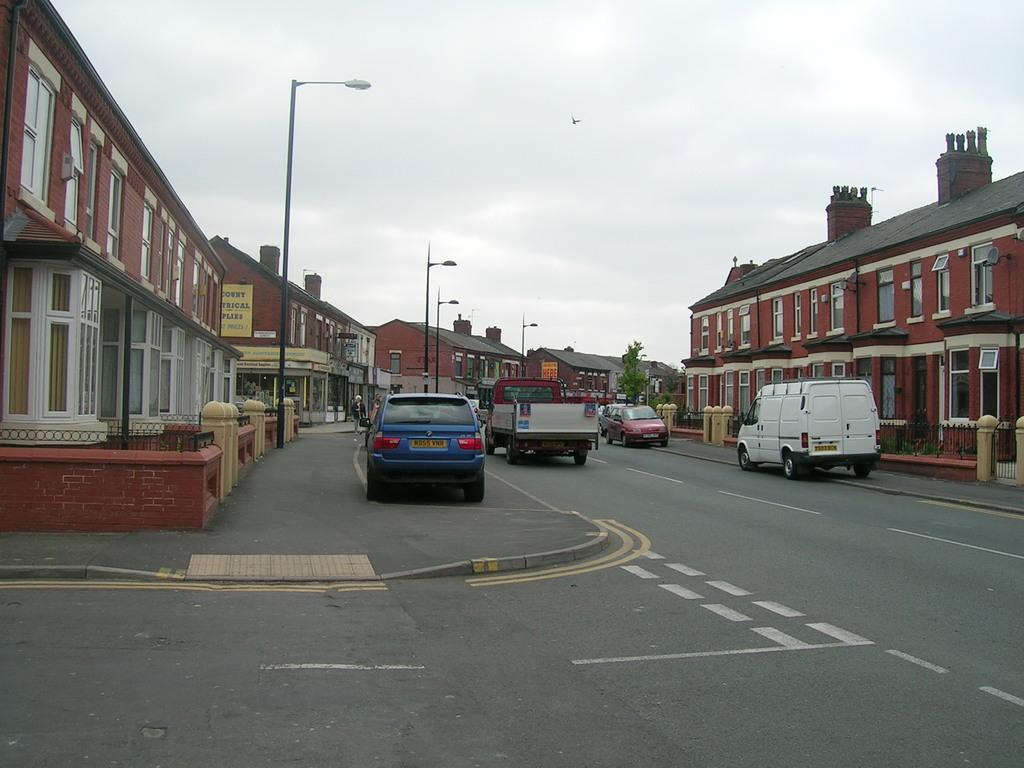What type of structures can be seen in the image? There are buildings in the image. What can be seen near the buildings? There is a railing and a fencing wall in the image. What are the light sources in the image? There are light poles in the image. What type of advertisement is present in the image? There are hoardings in the image. What type of vegetation is present in the image? There is a tree in the image. What is happening on the road in the image? Vehicles are passing on the road in the image. What is the condition of the sky in the image? The sky is visible and appears to be cloudy in the image. What type of bells can be heard ringing in the image? There are no bells present in the image, and therefore no sound can be heard. 